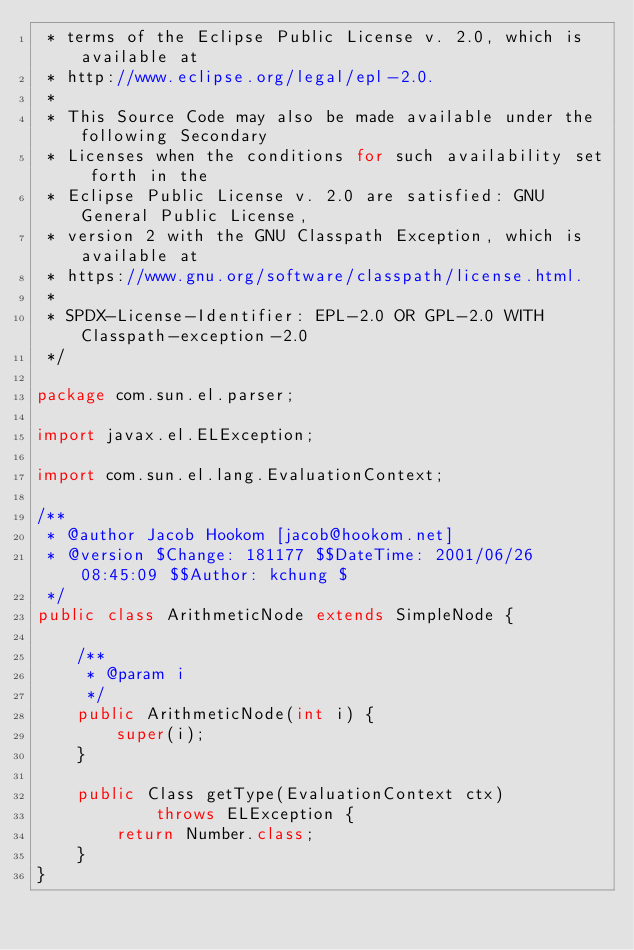Convert code to text. <code><loc_0><loc_0><loc_500><loc_500><_Java_> * terms of the Eclipse Public License v. 2.0, which is available at
 * http://www.eclipse.org/legal/epl-2.0.
 *
 * This Source Code may also be made available under the following Secondary
 * Licenses when the conditions for such availability set forth in the
 * Eclipse Public License v. 2.0 are satisfied: GNU General Public License,
 * version 2 with the GNU Classpath Exception, which is available at
 * https://www.gnu.org/software/classpath/license.html.
 *
 * SPDX-License-Identifier: EPL-2.0 OR GPL-2.0 WITH Classpath-exception-2.0
 */

package com.sun.el.parser;

import javax.el.ELException;

import com.sun.el.lang.EvaluationContext;

/**
 * @author Jacob Hookom [jacob@hookom.net]
 * @version $Change: 181177 $$DateTime: 2001/06/26 08:45:09 $$Author: kchung $
 */
public class ArithmeticNode extends SimpleNode {

    /**
     * @param i
     */
    public ArithmeticNode(int i) {
        super(i);
    }

    public Class getType(EvaluationContext ctx)
            throws ELException {
        return Number.class;
    }
}
</code> 